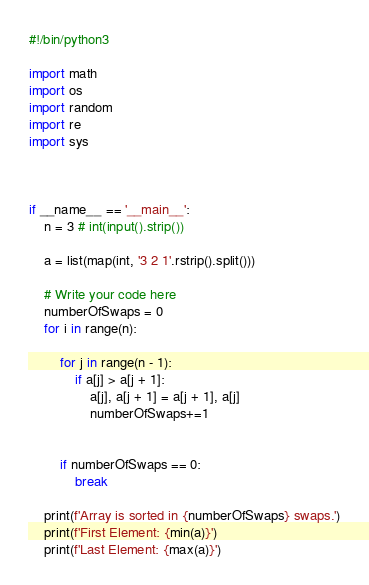<code> <loc_0><loc_0><loc_500><loc_500><_Python_>#!/bin/python3

import math
import os
import random
import re
import sys



if __name__ == '__main__':
	n = 3 # int(input().strip())

	a = list(map(int, '3 2 1'.rstrip().split()))

	# Write your code here
	numberOfSwaps = 0
	for i in range(n):
		
		for j in range(n - 1):
			if a[j] > a[j + 1]:
				a[j], a[j + 1] = a[j + 1], a[j]
				numberOfSwaps+=1

		
		if numberOfSwaps == 0:
			break

	print(f'Array is sorted in {numberOfSwaps} swaps.')
	print(f'First Element: {min(a)}')
	print(f'Last Element: {max(a)}')</code> 